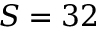<formula> <loc_0><loc_0><loc_500><loc_500>S = 3 2</formula> 